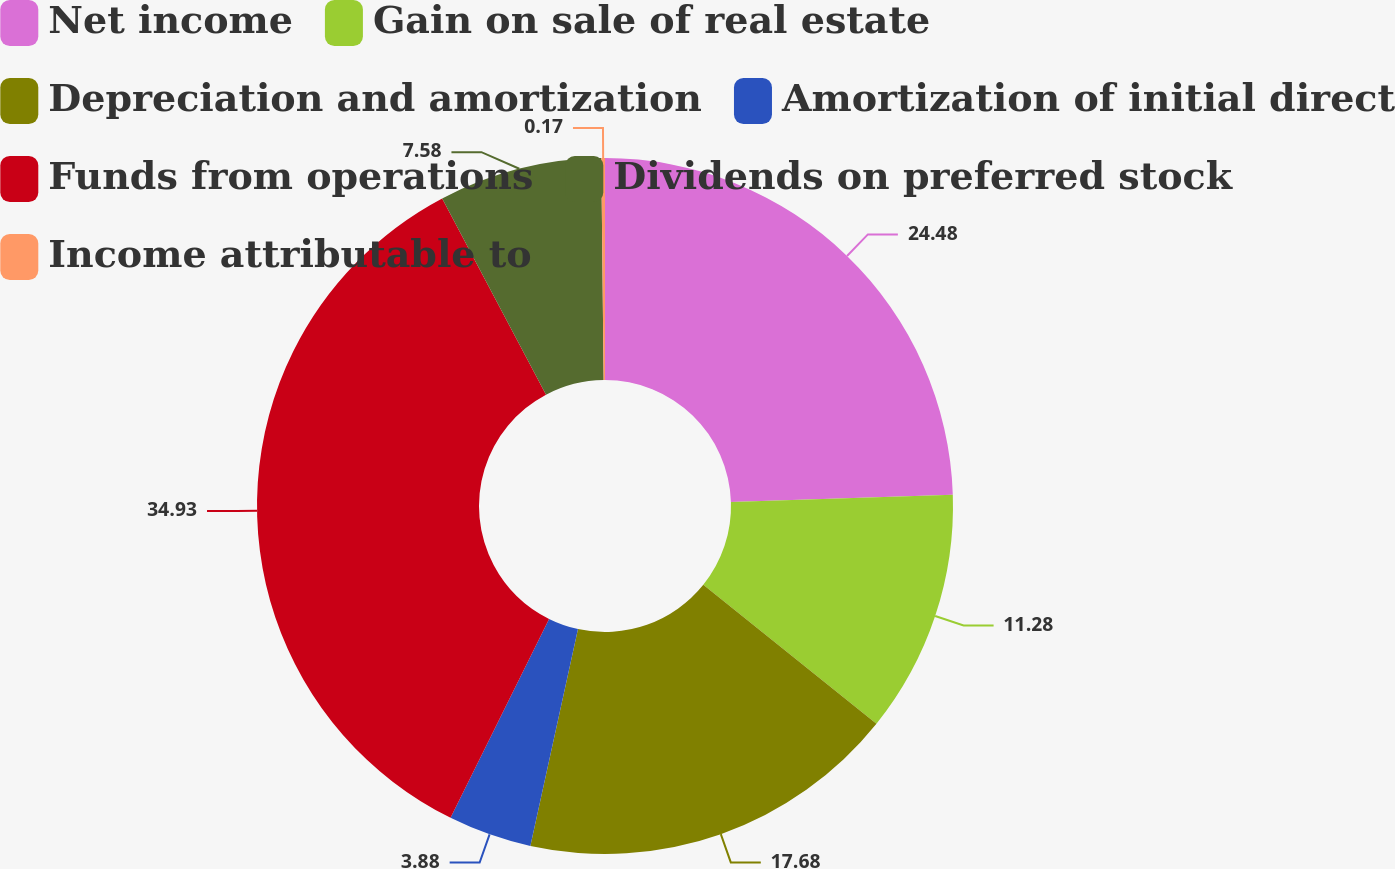Convert chart to OTSL. <chart><loc_0><loc_0><loc_500><loc_500><pie_chart><fcel>Net income<fcel>Gain on sale of real estate<fcel>Depreciation and amortization<fcel>Amortization of initial direct<fcel>Funds from operations<fcel>Dividends on preferred stock<fcel>Income attributable to<nl><fcel>24.48%<fcel>11.28%<fcel>17.68%<fcel>3.88%<fcel>34.93%<fcel>7.58%<fcel>0.17%<nl></chart> 